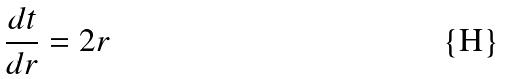Convert formula to latex. <formula><loc_0><loc_0><loc_500><loc_500>\frac { d t } { d r } = 2 r</formula> 